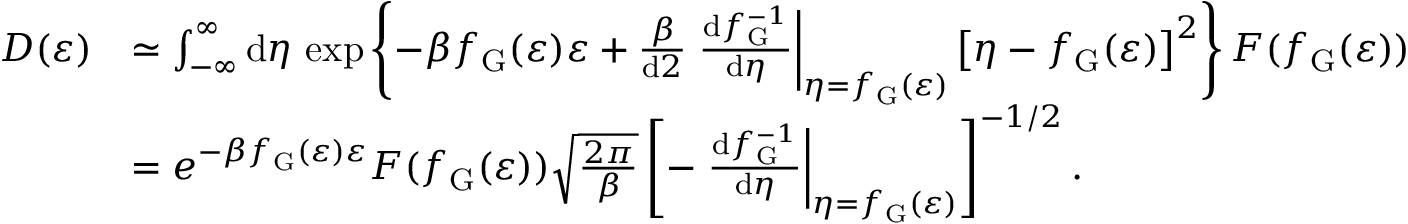Convert formula to latex. <formula><loc_0><loc_0><loc_500><loc_500>\begin{array} { r l } { D ( \varepsilon ) } & { \simeq \int _ { - \infty } ^ { \infty } d \eta \, \exp \left \{ - \beta f _ { G } ( \varepsilon ) \varepsilon + \frac { \beta } { d 2 } \frac { d f _ { G } ^ { - 1 } } { d \eta } \right | _ { \eta = f _ { G } ( \varepsilon ) } \left [ \eta - f _ { G } ( \varepsilon ) \right ] ^ { 2 } \right \} F ( f _ { G } ( \varepsilon ) ) } \\ & { = e ^ { - \beta f _ { G } ( \varepsilon ) \varepsilon } F ( f _ { G } ( \varepsilon ) ) \sqrt { \frac { 2 \pi } { \beta } } \left [ - \frac { d f _ { G } ^ { - 1 } } { d \eta } \right | _ { \eta = f _ { G } ( \varepsilon ) } \right ] ^ { - 1 / 2 } . } \end{array}</formula> 